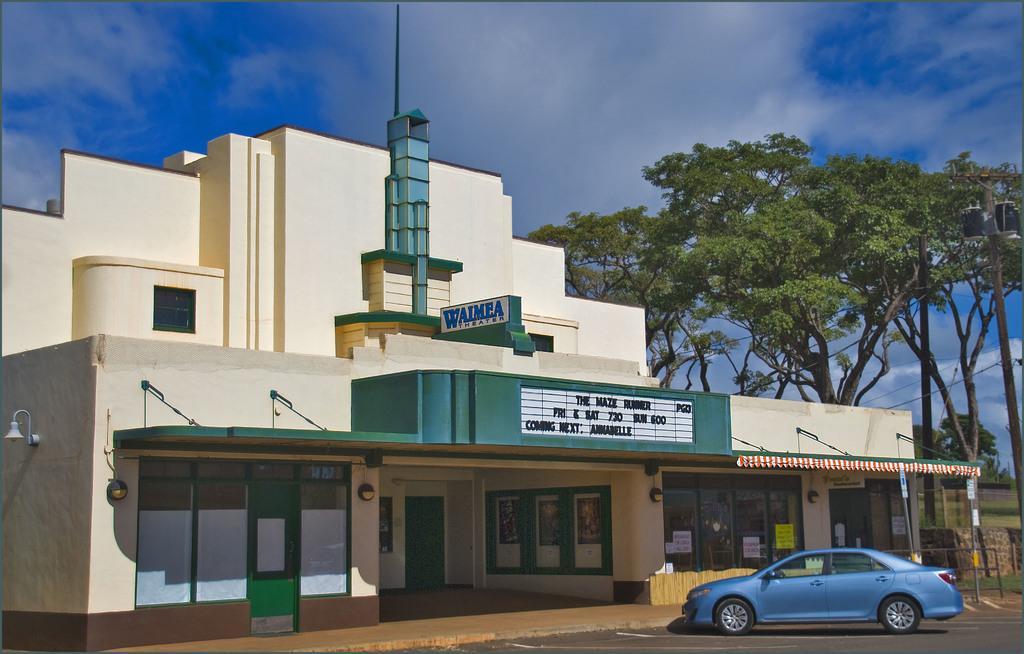Can you describe this image briefly? In this image, we can see a building beside trees. There is a car in front of the building. In the background of the image, there is a sky. 